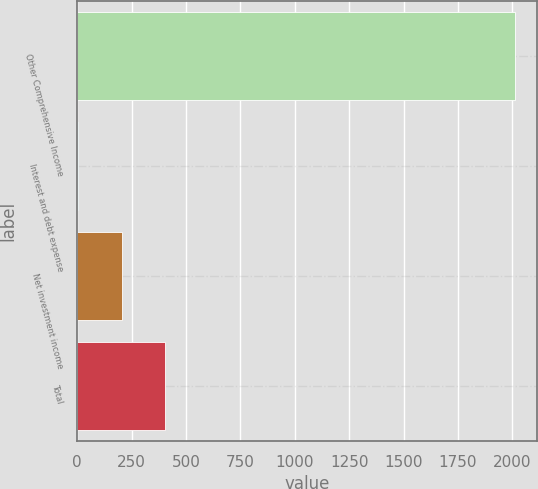Convert chart. <chart><loc_0><loc_0><loc_500><loc_500><bar_chart><fcel>Other Comprehensive Income<fcel>Interest and debt expense<fcel>Net investment income<fcel>Total<nl><fcel>2011<fcel>4<fcel>204.7<fcel>405.4<nl></chart> 